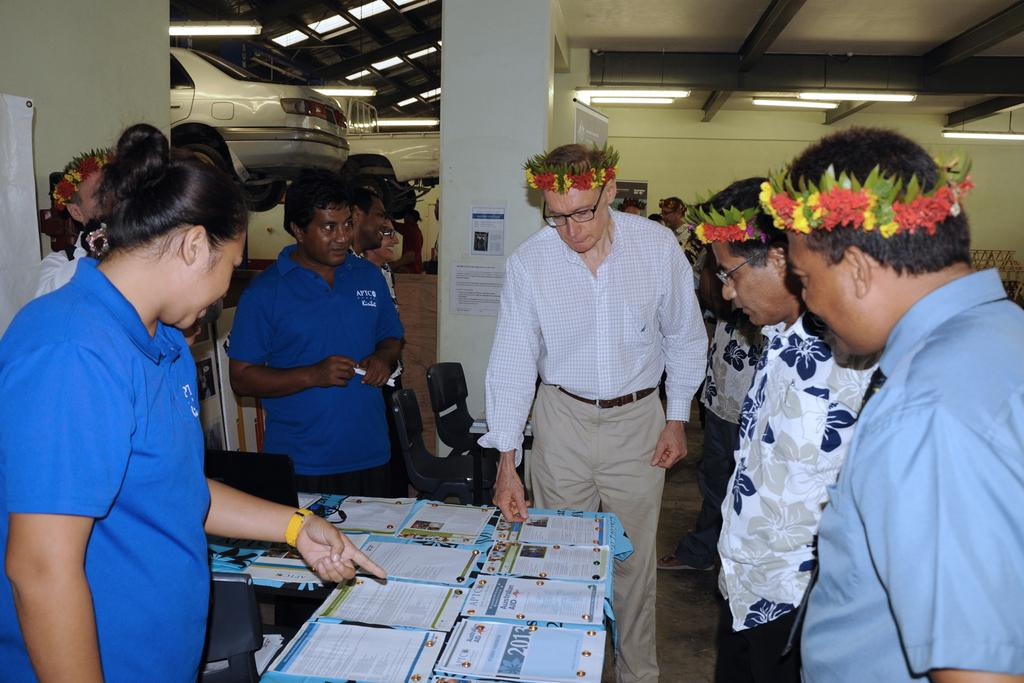What is the main subject of the image? The main subject of the image is a group of people standing. What objects are on the tables in the image? There are papers on the tables. What electronic device is visible in the image? There is a laptop visible in the image. What type of furniture is present in the image? Chairs are present in the image. What is the purpose of the papers on the wall? Papers are stuck to the wall, possibly for display or reference. What can be seen in the background of the image? Vehicles and lights are visible in the image. How many crows are sitting on the chairs in the image? There are no crows present in the image; it features a group of people, papers, a laptop, chairs, papers on the wall, vehicles, and lights. 